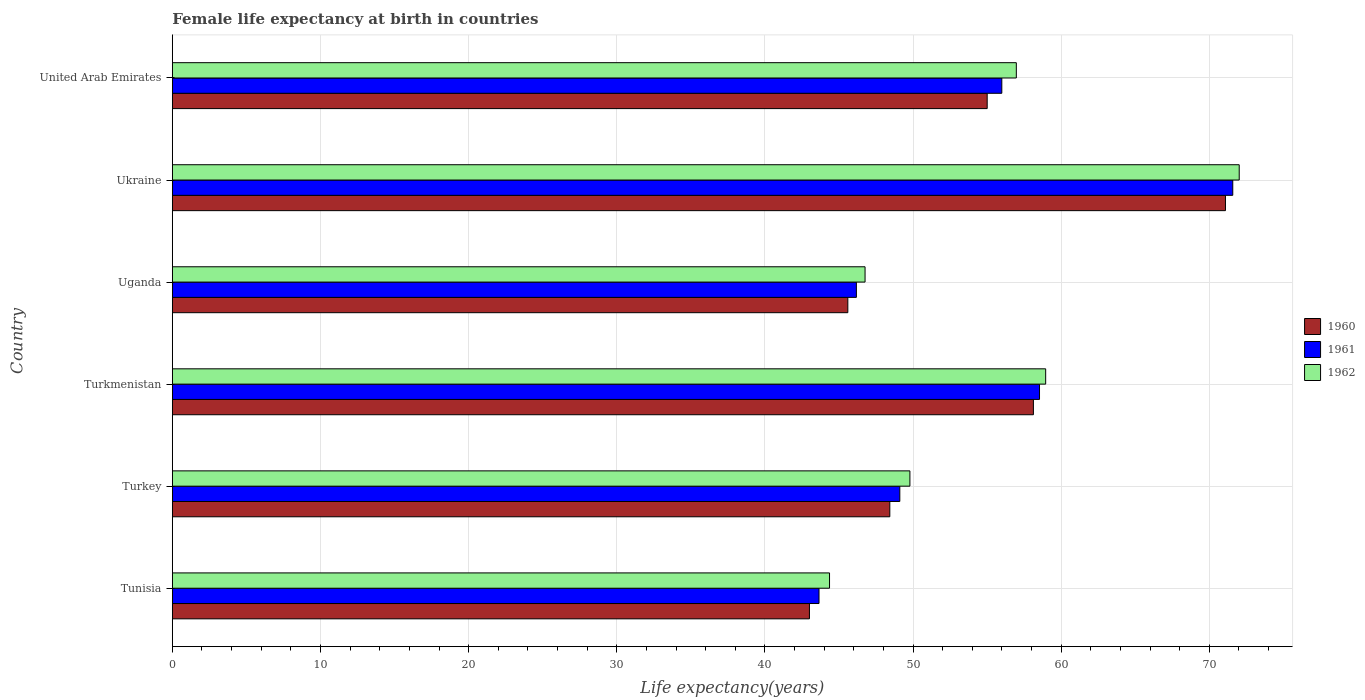How many different coloured bars are there?
Make the answer very short. 3. How many groups of bars are there?
Make the answer very short. 6. Are the number of bars per tick equal to the number of legend labels?
Your answer should be very brief. Yes. What is the label of the 4th group of bars from the top?
Keep it short and to the point. Turkmenistan. In how many cases, is the number of bars for a given country not equal to the number of legend labels?
Your answer should be compact. 0. What is the female life expectancy at birth in 1961 in Turkmenistan?
Keep it short and to the point. 58.54. Across all countries, what is the maximum female life expectancy at birth in 1962?
Keep it short and to the point. 72.02. Across all countries, what is the minimum female life expectancy at birth in 1961?
Make the answer very short. 43.65. In which country was the female life expectancy at birth in 1961 maximum?
Offer a terse response. Ukraine. In which country was the female life expectancy at birth in 1960 minimum?
Offer a very short reply. Tunisia. What is the total female life expectancy at birth in 1962 in the graph?
Provide a succinct answer. 328.86. What is the difference between the female life expectancy at birth in 1962 in Turkey and that in Ukraine?
Make the answer very short. -22.23. What is the difference between the female life expectancy at birth in 1960 in Uganda and the female life expectancy at birth in 1961 in United Arab Emirates?
Offer a very short reply. -10.4. What is the average female life expectancy at birth in 1962 per country?
Provide a short and direct response. 54.81. What is the difference between the female life expectancy at birth in 1962 and female life expectancy at birth in 1960 in Turkmenistan?
Your answer should be very brief. 0.83. In how many countries, is the female life expectancy at birth in 1961 greater than 16 years?
Your answer should be very brief. 6. What is the ratio of the female life expectancy at birth in 1962 in Turkey to that in Turkmenistan?
Provide a succinct answer. 0.84. Is the female life expectancy at birth in 1960 in Turkmenistan less than that in Ukraine?
Provide a short and direct response. Yes. Is the difference between the female life expectancy at birth in 1962 in Uganda and Ukraine greater than the difference between the female life expectancy at birth in 1960 in Uganda and Ukraine?
Provide a succinct answer. Yes. What is the difference between the highest and the second highest female life expectancy at birth in 1962?
Offer a terse response. 13.06. What is the difference between the highest and the lowest female life expectancy at birth in 1961?
Make the answer very short. 27.93. In how many countries, is the female life expectancy at birth in 1961 greater than the average female life expectancy at birth in 1961 taken over all countries?
Provide a succinct answer. 3. Is the sum of the female life expectancy at birth in 1962 in Turkmenistan and Uganda greater than the maximum female life expectancy at birth in 1960 across all countries?
Your answer should be compact. Yes. Is it the case that in every country, the sum of the female life expectancy at birth in 1962 and female life expectancy at birth in 1961 is greater than the female life expectancy at birth in 1960?
Provide a succinct answer. Yes. Are all the bars in the graph horizontal?
Your answer should be very brief. Yes. How many countries are there in the graph?
Provide a short and direct response. 6. Are the values on the major ticks of X-axis written in scientific E-notation?
Provide a short and direct response. No. Does the graph contain any zero values?
Your answer should be very brief. No. Does the graph contain grids?
Provide a succinct answer. Yes. How many legend labels are there?
Your response must be concise. 3. How are the legend labels stacked?
Offer a very short reply. Vertical. What is the title of the graph?
Make the answer very short. Female life expectancy at birth in countries. Does "1979" appear as one of the legend labels in the graph?
Make the answer very short. No. What is the label or title of the X-axis?
Ensure brevity in your answer.  Life expectancy(years). What is the Life expectancy(years) in 1960 in Tunisia?
Provide a succinct answer. 43.01. What is the Life expectancy(years) of 1961 in Tunisia?
Keep it short and to the point. 43.65. What is the Life expectancy(years) of 1962 in Tunisia?
Ensure brevity in your answer.  44.36. What is the Life expectancy(years) in 1960 in Turkey?
Ensure brevity in your answer.  48.43. What is the Life expectancy(years) of 1961 in Turkey?
Your response must be concise. 49.11. What is the Life expectancy(years) of 1962 in Turkey?
Provide a short and direct response. 49.79. What is the Life expectancy(years) of 1960 in Turkmenistan?
Your answer should be very brief. 58.13. What is the Life expectancy(years) of 1961 in Turkmenistan?
Ensure brevity in your answer.  58.54. What is the Life expectancy(years) in 1962 in Turkmenistan?
Make the answer very short. 58.95. What is the Life expectancy(years) in 1960 in Uganda?
Ensure brevity in your answer.  45.6. What is the Life expectancy(years) of 1961 in Uganda?
Offer a very short reply. 46.18. What is the Life expectancy(years) of 1962 in Uganda?
Ensure brevity in your answer.  46.76. What is the Life expectancy(years) in 1960 in Ukraine?
Offer a terse response. 71.09. What is the Life expectancy(years) in 1961 in Ukraine?
Provide a succinct answer. 71.58. What is the Life expectancy(years) in 1962 in Ukraine?
Your answer should be compact. 72.02. What is the Life expectancy(years) of 1960 in United Arab Emirates?
Offer a terse response. 55.01. What is the Life expectancy(years) in 1961 in United Arab Emirates?
Offer a very short reply. 55.99. What is the Life expectancy(years) in 1962 in United Arab Emirates?
Keep it short and to the point. 56.97. Across all countries, what is the maximum Life expectancy(years) of 1960?
Provide a succinct answer. 71.09. Across all countries, what is the maximum Life expectancy(years) of 1961?
Keep it short and to the point. 71.58. Across all countries, what is the maximum Life expectancy(years) of 1962?
Offer a very short reply. 72.02. Across all countries, what is the minimum Life expectancy(years) of 1960?
Your answer should be compact. 43.01. Across all countries, what is the minimum Life expectancy(years) in 1961?
Your response must be concise. 43.65. Across all countries, what is the minimum Life expectancy(years) of 1962?
Your answer should be very brief. 44.36. What is the total Life expectancy(years) of 1960 in the graph?
Keep it short and to the point. 321.26. What is the total Life expectancy(years) of 1961 in the graph?
Ensure brevity in your answer.  325.05. What is the total Life expectancy(years) of 1962 in the graph?
Make the answer very short. 328.86. What is the difference between the Life expectancy(years) in 1960 in Tunisia and that in Turkey?
Offer a terse response. -5.43. What is the difference between the Life expectancy(years) of 1961 in Tunisia and that in Turkey?
Keep it short and to the point. -5.46. What is the difference between the Life expectancy(years) of 1962 in Tunisia and that in Turkey?
Give a very brief answer. -5.43. What is the difference between the Life expectancy(years) of 1960 in Tunisia and that in Turkmenistan?
Ensure brevity in your answer.  -15.12. What is the difference between the Life expectancy(years) in 1961 in Tunisia and that in Turkmenistan?
Provide a succinct answer. -14.88. What is the difference between the Life expectancy(years) of 1962 in Tunisia and that in Turkmenistan?
Your response must be concise. -14.59. What is the difference between the Life expectancy(years) in 1960 in Tunisia and that in Uganda?
Offer a very short reply. -2.59. What is the difference between the Life expectancy(years) of 1961 in Tunisia and that in Uganda?
Ensure brevity in your answer.  -2.52. What is the difference between the Life expectancy(years) in 1962 in Tunisia and that in Uganda?
Keep it short and to the point. -2.4. What is the difference between the Life expectancy(years) of 1960 in Tunisia and that in Ukraine?
Your answer should be very brief. -28.08. What is the difference between the Life expectancy(years) in 1961 in Tunisia and that in Ukraine?
Keep it short and to the point. -27.93. What is the difference between the Life expectancy(years) in 1962 in Tunisia and that in Ukraine?
Give a very brief answer. -27.66. What is the difference between the Life expectancy(years) in 1960 in Tunisia and that in United Arab Emirates?
Make the answer very short. -12. What is the difference between the Life expectancy(years) in 1961 in Tunisia and that in United Arab Emirates?
Ensure brevity in your answer.  -12.34. What is the difference between the Life expectancy(years) of 1962 in Tunisia and that in United Arab Emirates?
Keep it short and to the point. -12.61. What is the difference between the Life expectancy(years) of 1960 in Turkey and that in Turkmenistan?
Make the answer very short. -9.69. What is the difference between the Life expectancy(years) of 1961 in Turkey and that in Turkmenistan?
Make the answer very short. -9.43. What is the difference between the Life expectancy(years) in 1962 in Turkey and that in Turkmenistan?
Your response must be concise. -9.16. What is the difference between the Life expectancy(years) in 1960 in Turkey and that in Uganda?
Your response must be concise. 2.83. What is the difference between the Life expectancy(years) of 1961 in Turkey and that in Uganda?
Your response must be concise. 2.93. What is the difference between the Life expectancy(years) of 1962 in Turkey and that in Uganda?
Your response must be concise. 3.03. What is the difference between the Life expectancy(years) of 1960 in Turkey and that in Ukraine?
Keep it short and to the point. -22.66. What is the difference between the Life expectancy(years) in 1961 in Turkey and that in Ukraine?
Offer a very short reply. -22.48. What is the difference between the Life expectancy(years) in 1962 in Turkey and that in Ukraine?
Keep it short and to the point. -22.23. What is the difference between the Life expectancy(years) of 1960 in Turkey and that in United Arab Emirates?
Give a very brief answer. -6.57. What is the difference between the Life expectancy(years) in 1961 in Turkey and that in United Arab Emirates?
Provide a short and direct response. -6.88. What is the difference between the Life expectancy(years) in 1962 in Turkey and that in United Arab Emirates?
Provide a succinct answer. -7.18. What is the difference between the Life expectancy(years) of 1960 in Turkmenistan and that in Uganda?
Ensure brevity in your answer.  12.53. What is the difference between the Life expectancy(years) of 1961 in Turkmenistan and that in Uganda?
Give a very brief answer. 12.36. What is the difference between the Life expectancy(years) in 1962 in Turkmenistan and that in Uganda?
Provide a short and direct response. 12.19. What is the difference between the Life expectancy(years) of 1960 in Turkmenistan and that in Ukraine?
Your response must be concise. -12.96. What is the difference between the Life expectancy(years) in 1961 in Turkmenistan and that in Ukraine?
Offer a terse response. -13.05. What is the difference between the Life expectancy(years) in 1962 in Turkmenistan and that in Ukraine?
Provide a succinct answer. -13.06. What is the difference between the Life expectancy(years) of 1960 in Turkmenistan and that in United Arab Emirates?
Ensure brevity in your answer.  3.12. What is the difference between the Life expectancy(years) in 1961 in Turkmenistan and that in United Arab Emirates?
Your response must be concise. 2.54. What is the difference between the Life expectancy(years) in 1962 in Turkmenistan and that in United Arab Emirates?
Your answer should be compact. 1.98. What is the difference between the Life expectancy(years) of 1960 in Uganda and that in Ukraine?
Keep it short and to the point. -25.49. What is the difference between the Life expectancy(years) of 1961 in Uganda and that in Ukraine?
Provide a succinct answer. -25.41. What is the difference between the Life expectancy(years) in 1962 in Uganda and that in Ukraine?
Your answer should be very brief. -25.26. What is the difference between the Life expectancy(years) of 1960 in Uganda and that in United Arab Emirates?
Keep it short and to the point. -9.41. What is the difference between the Life expectancy(years) in 1961 in Uganda and that in United Arab Emirates?
Offer a terse response. -9.82. What is the difference between the Life expectancy(years) in 1962 in Uganda and that in United Arab Emirates?
Provide a succinct answer. -10.21. What is the difference between the Life expectancy(years) of 1960 in Ukraine and that in United Arab Emirates?
Your answer should be compact. 16.09. What is the difference between the Life expectancy(years) in 1961 in Ukraine and that in United Arab Emirates?
Your response must be concise. 15.59. What is the difference between the Life expectancy(years) of 1962 in Ukraine and that in United Arab Emirates?
Your answer should be compact. 15.05. What is the difference between the Life expectancy(years) of 1960 in Tunisia and the Life expectancy(years) of 1961 in Turkey?
Ensure brevity in your answer.  -6.1. What is the difference between the Life expectancy(years) in 1960 in Tunisia and the Life expectancy(years) in 1962 in Turkey?
Give a very brief answer. -6.78. What is the difference between the Life expectancy(years) of 1961 in Tunisia and the Life expectancy(years) of 1962 in Turkey?
Provide a succinct answer. -6.14. What is the difference between the Life expectancy(years) in 1960 in Tunisia and the Life expectancy(years) in 1961 in Turkmenistan?
Provide a succinct answer. -15.53. What is the difference between the Life expectancy(years) in 1960 in Tunisia and the Life expectancy(years) in 1962 in Turkmenistan?
Provide a succinct answer. -15.95. What is the difference between the Life expectancy(years) of 1961 in Tunisia and the Life expectancy(years) of 1962 in Turkmenistan?
Offer a terse response. -15.3. What is the difference between the Life expectancy(years) in 1960 in Tunisia and the Life expectancy(years) in 1961 in Uganda?
Your answer should be very brief. -3.17. What is the difference between the Life expectancy(years) in 1960 in Tunisia and the Life expectancy(years) in 1962 in Uganda?
Make the answer very short. -3.75. What is the difference between the Life expectancy(years) in 1961 in Tunisia and the Life expectancy(years) in 1962 in Uganda?
Provide a short and direct response. -3.11. What is the difference between the Life expectancy(years) of 1960 in Tunisia and the Life expectancy(years) of 1961 in Ukraine?
Your response must be concise. -28.58. What is the difference between the Life expectancy(years) of 1960 in Tunisia and the Life expectancy(years) of 1962 in Ukraine?
Keep it short and to the point. -29.01. What is the difference between the Life expectancy(years) in 1961 in Tunisia and the Life expectancy(years) in 1962 in Ukraine?
Your response must be concise. -28.37. What is the difference between the Life expectancy(years) in 1960 in Tunisia and the Life expectancy(years) in 1961 in United Arab Emirates?
Provide a succinct answer. -12.99. What is the difference between the Life expectancy(years) in 1960 in Tunisia and the Life expectancy(years) in 1962 in United Arab Emirates?
Ensure brevity in your answer.  -13.97. What is the difference between the Life expectancy(years) in 1961 in Tunisia and the Life expectancy(years) in 1962 in United Arab Emirates?
Your response must be concise. -13.32. What is the difference between the Life expectancy(years) of 1960 in Turkey and the Life expectancy(years) of 1961 in Turkmenistan?
Your response must be concise. -10.11. What is the difference between the Life expectancy(years) in 1960 in Turkey and the Life expectancy(years) in 1962 in Turkmenistan?
Your answer should be very brief. -10.52. What is the difference between the Life expectancy(years) of 1961 in Turkey and the Life expectancy(years) of 1962 in Turkmenistan?
Provide a succinct answer. -9.85. What is the difference between the Life expectancy(years) in 1960 in Turkey and the Life expectancy(years) in 1961 in Uganda?
Your response must be concise. 2.26. What is the difference between the Life expectancy(years) in 1960 in Turkey and the Life expectancy(years) in 1962 in Uganda?
Your response must be concise. 1.67. What is the difference between the Life expectancy(years) of 1961 in Turkey and the Life expectancy(years) of 1962 in Uganda?
Provide a short and direct response. 2.35. What is the difference between the Life expectancy(years) in 1960 in Turkey and the Life expectancy(years) in 1961 in Ukraine?
Make the answer very short. -23.15. What is the difference between the Life expectancy(years) of 1960 in Turkey and the Life expectancy(years) of 1962 in Ukraine?
Your answer should be very brief. -23.59. What is the difference between the Life expectancy(years) in 1961 in Turkey and the Life expectancy(years) in 1962 in Ukraine?
Your answer should be compact. -22.91. What is the difference between the Life expectancy(years) in 1960 in Turkey and the Life expectancy(years) in 1961 in United Arab Emirates?
Your answer should be compact. -7.56. What is the difference between the Life expectancy(years) of 1960 in Turkey and the Life expectancy(years) of 1962 in United Arab Emirates?
Your answer should be compact. -8.54. What is the difference between the Life expectancy(years) of 1961 in Turkey and the Life expectancy(years) of 1962 in United Arab Emirates?
Give a very brief answer. -7.87. What is the difference between the Life expectancy(years) in 1960 in Turkmenistan and the Life expectancy(years) in 1961 in Uganda?
Keep it short and to the point. 11.95. What is the difference between the Life expectancy(years) in 1960 in Turkmenistan and the Life expectancy(years) in 1962 in Uganda?
Offer a very short reply. 11.36. What is the difference between the Life expectancy(years) in 1961 in Turkmenistan and the Life expectancy(years) in 1962 in Uganda?
Offer a terse response. 11.78. What is the difference between the Life expectancy(years) of 1960 in Turkmenistan and the Life expectancy(years) of 1961 in Ukraine?
Make the answer very short. -13.46. What is the difference between the Life expectancy(years) in 1960 in Turkmenistan and the Life expectancy(years) in 1962 in Ukraine?
Your response must be concise. -13.89. What is the difference between the Life expectancy(years) of 1961 in Turkmenistan and the Life expectancy(years) of 1962 in Ukraine?
Ensure brevity in your answer.  -13.48. What is the difference between the Life expectancy(years) in 1960 in Turkmenistan and the Life expectancy(years) in 1961 in United Arab Emirates?
Your response must be concise. 2.13. What is the difference between the Life expectancy(years) in 1960 in Turkmenistan and the Life expectancy(years) in 1962 in United Arab Emirates?
Make the answer very short. 1.15. What is the difference between the Life expectancy(years) of 1961 in Turkmenistan and the Life expectancy(years) of 1962 in United Arab Emirates?
Provide a succinct answer. 1.56. What is the difference between the Life expectancy(years) of 1960 in Uganda and the Life expectancy(years) of 1961 in Ukraine?
Keep it short and to the point. -25.99. What is the difference between the Life expectancy(years) in 1960 in Uganda and the Life expectancy(years) in 1962 in Ukraine?
Your answer should be compact. -26.42. What is the difference between the Life expectancy(years) of 1961 in Uganda and the Life expectancy(years) of 1962 in Ukraine?
Your answer should be compact. -25.84. What is the difference between the Life expectancy(years) in 1960 in Uganda and the Life expectancy(years) in 1961 in United Arab Emirates?
Ensure brevity in your answer.  -10.39. What is the difference between the Life expectancy(years) in 1960 in Uganda and the Life expectancy(years) in 1962 in United Arab Emirates?
Your response must be concise. -11.38. What is the difference between the Life expectancy(years) in 1961 in Uganda and the Life expectancy(years) in 1962 in United Arab Emirates?
Give a very brief answer. -10.8. What is the difference between the Life expectancy(years) of 1960 in Ukraine and the Life expectancy(years) of 1961 in United Arab Emirates?
Your answer should be compact. 15.1. What is the difference between the Life expectancy(years) of 1960 in Ukraine and the Life expectancy(years) of 1962 in United Arab Emirates?
Make the answer very short. 14.12. What is the difference between the Life expectancy(years) of 1961 in Ukraine and the Life expectancy(years) of 1962 in United Arab Emirates?
Your answer should be very brief. 14.61. What is the average Life expectancy(years) of 1960 per country?
Provide a short and direct response. 53.54. What is the average Life expectancy(years) of 1961 per country?
Ensure brevity in your answer.  54.18. What is the average Life expectancy(years) of 1962 per country?
Your answer should be compact. 54.81. What is the difference between the Life expectancy(years) in 1960 and Life expectancy(years) in 1961 in Tunisia?
Provide a succinct answer. -0.65. What is the difference between the Life expectancy(years) in 1960 and Life expectancy(years) in 1962 in Tunisia?
Your response must be concise. -1.36. What is the difference between the Life expectancy(years) in 1961 and Life expectancy(years) in 1962 in Tunisia?
Offer a terse response. -0.71. What is the difference between the Life expectancy(years) in 1960 and Life expectancy(years) in 1961 in Turkey?
Your response must be concise. -0.68. What is the difference between the Life expectancy(years) of 1960 and Life expectancy(years) of 1962 in Turkey?
Give a very brief answer. -1.36. What is the difference between the Life expectancy(years) of 1961 and Life expectancy(years) of 1962 in Turkey?
Your response must be concise. -0.68. What is the difference between the Life expectancy(years) of 1960 and Life expectancy(years) of 1961 in Turkmenistan?
Ensure brevity in your answer.  -0.41. What is the difference between the Life expectancy(years) of 1960 and Life expectancy(years) of 1962 in Turkmenistan?
Ensure brevity in your answer.  -0.83. What is the difference between the Life expectancy(years) in 1961 and Life expectancy(years) in 1962 in Turkmenistan?
Make the answer very short. -0.42. What is the difference between the Life expectancy(years) in 1960 and Life expectancy(years) in 1961 in Uganda?
Provide a short and direct response. -0.58. What is the difference between the Life expectancy(years) in 1960 and Life expectancy(years) in 1962 in Uganda?
Offer a terse response. -1.16. What is the difference between the Life expectancy(years) in 1961 and Life expectancy(years) in 1962 in Uganda?
Provide a succinct answer. -0.59. What is the difference between the Life expectancy(years) of 1960 and Life expectancy(years) of 1961 in Ukraine?
Your answer should be compact. -0.49. What is the difference between the Life expectancy(years) in 1960 and Life expectancy(years) in 1962 in Ukraine?
Provide a succinct answer. -0.93. What is the difference between the Life expectancy(years) in 1961 and Life expectancy(years) in 1962 in Ukraine?
Your response must be concise. -0.43. What is the difference between the Life expectancy(years) in 1960 and Life expectancy(years) in 1961 in United Arab Emirates?
Offer a terse response. -0.99. What is the difference between the Life expectancy(years) in 1960 and Life expectancy(years) in 1962 in United Arab Emirates?
Provide a succinct answer. -1.97. What is the difference between the Life expectancy(years) in 1961 and Life expectancy(years) in 1962 in United Arab Emirates?
Your answer should be very brief. -0.98. What is the ratio of the Life expectancy(years) of 1960 in Tunisia to that in Turkey?
Provide a short and direct response. 0.89. What is the ratio of the Life expectancy(years) in 1961 in Tunisia to that in Turkey?
Offer a very short reply. 0.89. What is the ratio of the Life expectancy(years) of 1962 in Tunisia to that in Turkey?
Your response must be concise. 0.89. What is the ratio of the Life expectancy(years) of 1960 in Tunisia to that in Turkmenistan?
Your answer should be compact. 0.74. What is the ratio of the Life expectancy(years) in 1961 in Tunisia to that in Turkmenistan?
Offer a very short reply. 0.75. What is the ratio of the Life expectancy(years) in 1962 in Tunisia to that in Turkmenistan?
Offer a terse response. 0.75. What is the ratio of the Life expectancy(years) of 1960 in Tunisia to that in Uganda?
Provide a short and direct response. 0.94. What is the ratio of the Life expectancy(years) in 1961 in Tunisia to that in Uganda?
Ensure brevity in your answer.  0.95. What is the ratio of the Life expectancy(years) in 1962 in Tunisia to that in Uganda?
Provide a short and direct response. 0.95. What is the ratio of the Life expectancy(years) in 1960 in Tunisia to that in Ukraine?
Offer a terse response. 0.6. What is the ratio of the Life expectancy(years) of 1961 in Tunisia to that in Ukraine?
Keep it short and to the point. 0.61. What is the ratio of the Life expectancy(years) of 1962 in Tunisia to that in Ukraine?
Your answer should be compact. 0.62. What is the ratio of the Life expectancy(years) in 1960 in Tunisia to that in United Arab Emirates?
Offer a very short reply. 0.78. What is the ratio of the Life expectancy(years) in 1961 in Tunisia to that in United Arab Emirates?
Make the answer very short. 0.78. What is the ratio of the Life expectancy(years) of 1962 in Tunisia to that in United Arab Emirates?
Your response must be concise. 0.78. What is the ratio of the Life expectancy(years) of 1960 in Turkey to that in Turkmenistan?
Your answer should be compact. 0.83. What is the ratio of the Life expectancy(years) of 1961 in Turkey to that in Turkmenistan?
Your answer should be compact. 0.84. What is the ratio of the Life expectancy(years) in 1962 in Turkey to that in Turkmenistan?
Keep it short and to the point. 0.84. What is the ratio of the Life expectancy(years) in 1960 in Turkey to that in Uganda?
Your answer should be compact. 1.06. What is the ratio of the Life expectancy(years) of 1961 in Turkey to that in Uganda?
Offer a very short reply. 1.06. What is the ratio of the Life expectancy(years) in 1962 in Turkey to that in Uganda?
Your answer should be compact. 1.06. What is the ratio of the Life expectancy(years) in 1960 in Turkey to that in Ukraine?
Your answer should be compact. 0.68. What is the ratio of the Life expectancy(years) of 1961 in Turkey to that in Ukraine?
Your answer should be compact. 0.69. What is the ratio of the Life expectancy(years) of 1962 in Turkey to that in Ukraine?
Make the answer very short. 0.69. What is the ratio of the Life expectancy(years) in 1960 in Turkey to that in United Arab Emirates?
Provide a short and direct response. 0.88. What is the ratio of the Life expectancy(years) of 1961 in Turkey to that in United Arab Emirates?
Keep it short and to the point. 0.88. What is the ratio of the Life expectancy(years) of 1962 in Turkey to that in United Arab Emirates?
Your answer should be compact. 0.87. What is the ratio of the Life expectancy(years) of 1960 in Turkmenistan to that in Uganda?
Provide a short and direct response. 1.27. What is the ratio of the Life expectancy(years) of 1961 in Turkmenistan to that in Uganda?
Offer a very short reply. 1.27. What is the ratio of the Life expectancy(years) of 1962 in Turkmenistan to that in Uganda?
Make the answer very short. 1.26. What is the ratio of the Life expectancy(years) of 1960 in Turkmenistan to that in Ukraine?
Your answer should be compact. 0.82. What is the ratio of the Life expectancy(years) in 1961 in Turkmenistan to that in Ukraine?
Give a very brief answer. 0.82. What is the ratio of the Life expectancy(years) in 1962 in Turkmenistan to that in Ukraine?
Offer a very short reply. 0.82. What is the ratio of the Life expectancy(years) in 1960 in Turkmenistan to that in United Arab Emirates?
Your response must be concise. 1.06. What is the ratio of the Life expectancy(years) in 1961 in Turkmenistan to that in United Arab Emirates?
Provide a short and direct response. 1.05. What is the ratio of the Life expectancy(years) in 1962 in Turkmenistan to that in United Arab Emirates?
Give a very brief answer. 1.03. What is the ratio of the Life expectancy(years) in 1960 in Uganda to that in Ukraine?
Your response must be concise. 0.64. What is the ratio of the Life expectancy(years) in 1961 in Uganda to that in Ukraine?
Keep it short and to the point. 0.65. What is the ratio of the Life expectancy(years) in 1962 in Uganda to that in Ukraine?
Your answer should be very brief. 0.65. What is the ratio of the Life expectancy(years) of 1960 in Uganda to that in United Arab Emirates?
Make the answer very short. 0.83. What is the ratio of the Life expectancy(years) of 1961 in Uganda to that in United Arab Emirates?
Ensure brevity in your answer.  0.82. What is the ratio of the Life expectancy(years) in 1962 in Uganda to that in United Arab Emirates?
Your answer should be very brief. 0.82. What is the ratio of the Life expectancy(years) of 1960 in Ukraine to that in United Arab Emirates?
Give a very brief answer. 1.29. What is the ratio of the Life expectancy(years) in 1961 in Ukraine to that in United Arab Emirates?
Ensure brevity in your answer.  1.28. What is the ratio of the Life expectancy(years) of 1962 in Ukraine to that in United Arab Emirates?
Provide a short and direct response. 1.26. What is the difference between the highest and the second highest Life expectancy(years) of 1960?
Give a very brief answer. 12.96. What is the difference between the highest and the second highest Life expectancy(years) in 1961?
Your response must be concise. 13.05. What is the difference between the highest and the second highest Life expectancy(years) in 1962?
Ensure brevity in your answer.  13.06. What is the difference between the highest and the lowest Life expectancy(years) of 1960?
Provide a short and direct response. 28.08. What is the difference between the highest and the lowest Life expectancy(years) in 1961?
Provide a succinct answer. 27.93. What is the difference between the highest and the lowest Life expectancy(years) of 1962?
Your answer should be very brief. 27.66. 